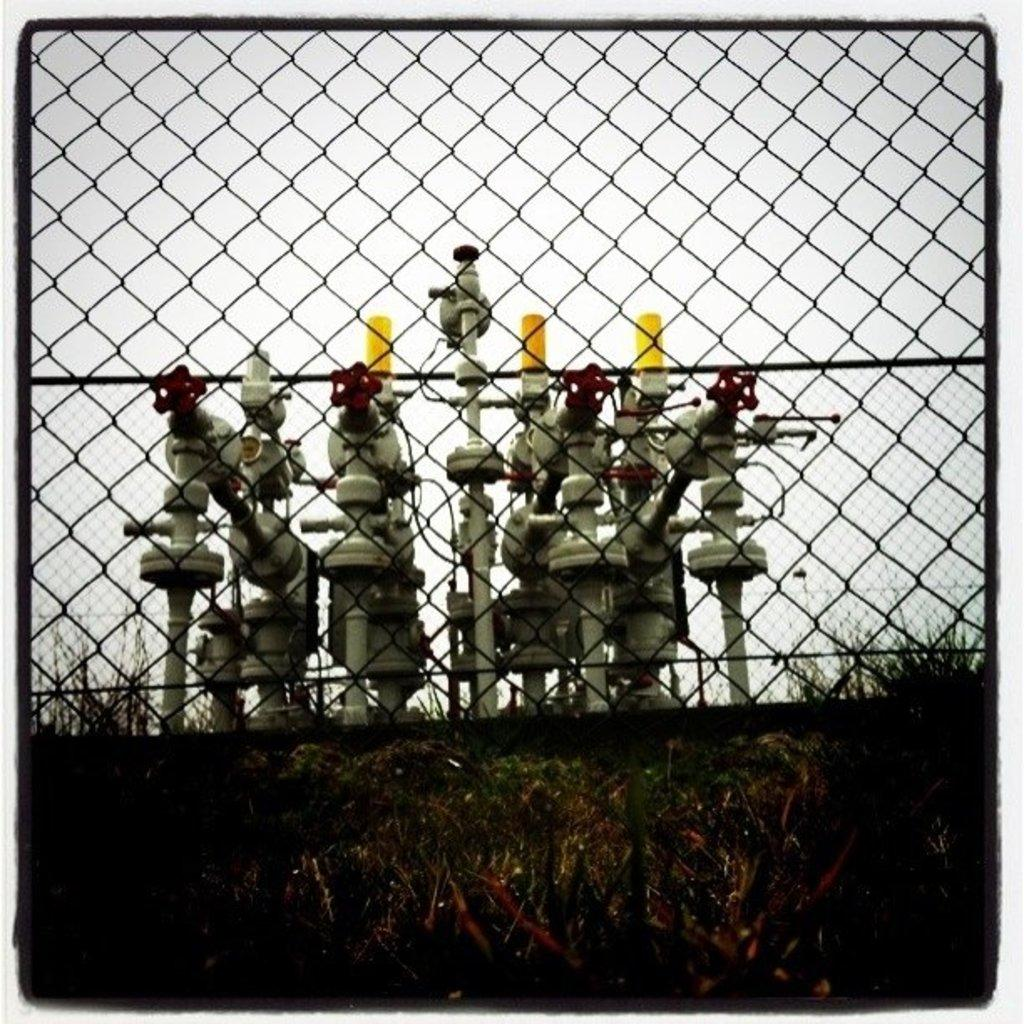What type of barrier is present in the image? There is a wire fence in the image. What can be seen behind the wire fence? There are gas pipelines visible behind the wire fence. What type of vegetation is present in the image? There is grass visible in the image. What is visible in the background of the image? The sky is visible in the background of the image. How many sheep are visible in the image? There are no sheep present in the image. What type of award has the actor received in the image? There is no actor or award mentioned in the image; it features a wire fence, gas pipelines, grass, and the sky. 